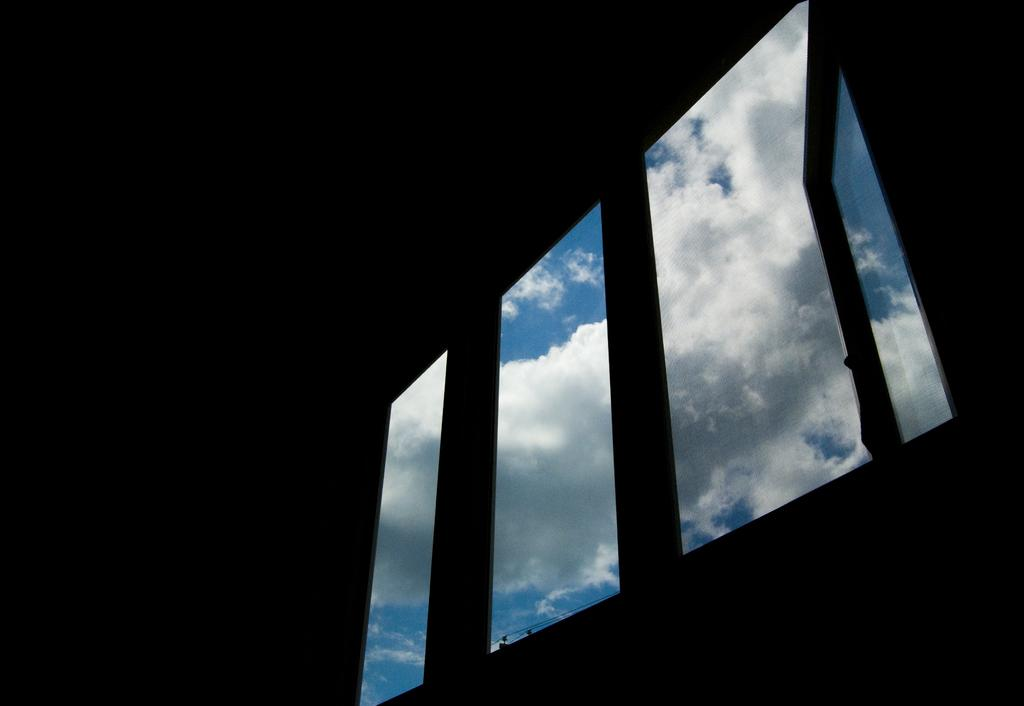What is located in the center of the image? There is a window in the center of the image. What can be seen through the window? The sky is visible in the image. What type of board is being used for educational purposes in the image? There is no board or educational activity present in the image; it only features a window and the sky. 